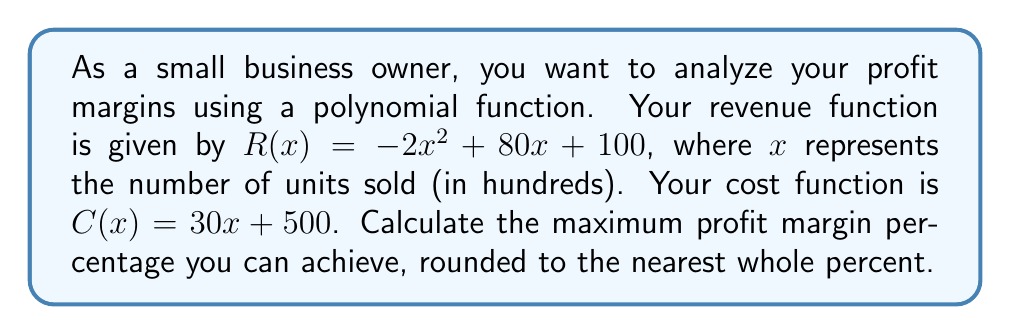What is the answer to this math problem? To solve this problem, we'll follow these steps:

1) First, let's define the profit function $P(x)$:
   $P(x) = R(x) - C(x)$
   $P(x) = (-2x^2 + 80x + 100) - (30x + 500)$
   $P(x) = -2x^2 + 50x - 400$

2) To find the maximum profit, we need to find the vertex of this quadratic function:
   $x = -\frac{b}{2a} = -\frac{50}{2(-2)} = \frac{25}{2} = 12.5$

3) The maximum profit occurs when $x = 12.5$ (1,250 units). Let's calculate this profit:
   $P(12.5) = -2(12.5)^2 + 50(12.5) - 400$
   $= -2(156.25) + 625 - 400$
   $= -312.5 + 625 - 400$
   $= -87.5 + 625 = 537.5$

4) Now, let's calculate the revenue at this point:
   $R(12.5) = -2(12.5)^2 + 80(12.5) + 100$
   $= -312.5 + 1000 + 100 = 787.5$

5) The profit margin percentage is calculated as:
   Profit Margin % = $\frac{\text{Profit}}{\text{Revenue}} \times 100\%$
   $= \frac{537.5}{787.5} \times 100\% \approx 68.25\%$

6) Rounding to the nearest whole percent gives us 68%.
Answer: The maximum profit margin percentage is 68%. 